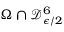<formula> <loc_0><loc_0><loc_500><loc_500>\Omega \cap \mathcal { D } _ { \epsilon / 2 } ^ { 6 }</formula> 